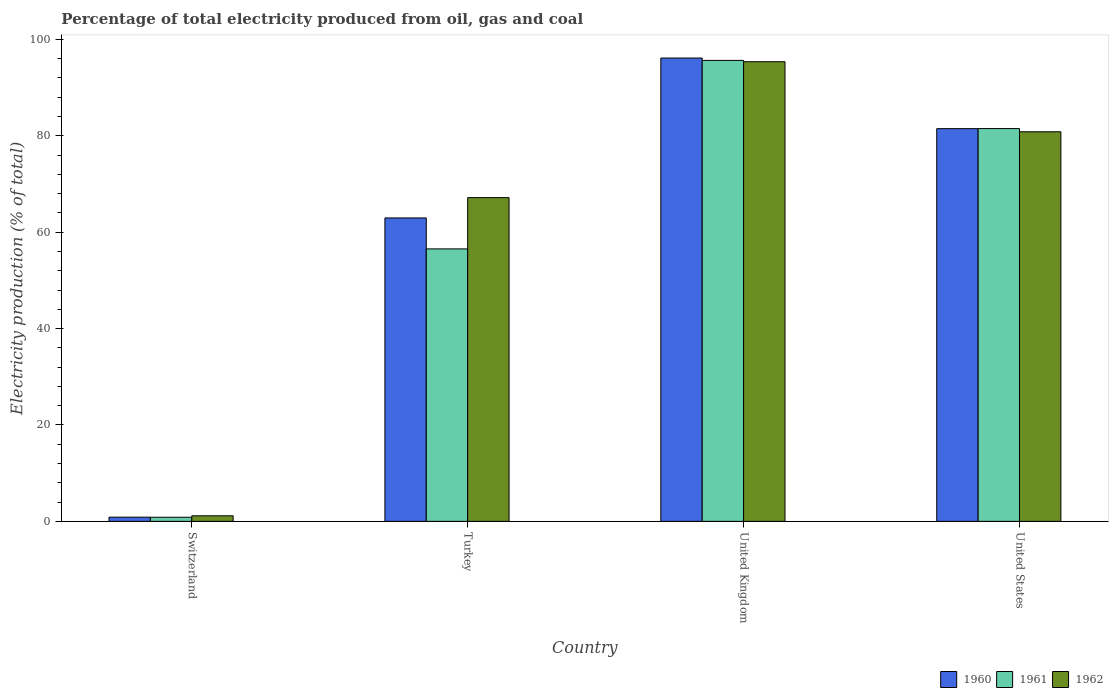How many different coloured bars are there?
Your answer should be very brief. 3. Are the number of bars per tick equal to the number of legend labels?
Keep it short and to the point. Yes. Are the number of bars on each tick of the X-axis equal?
Offer a very short reply. Yes. How many bars are there on the 1st tick from the right?
Provide a succinct answer. 3. What is the electricity production in in 1960 in Switzerland?
Your answer should be compact. 0.87. Across all countries, what is the maximum electricity production in in 1961?
Your answer should be very brief. 95.64. Across all countries, what is the minimum electricity production in in 1961?
Offer a very short reply. 0.85. In which country was the electricity production in in 1961 maximum?
Your answer should be compact. United Kingdom. In which country was the electricity production in in 1960 minimum?
Provide a short and direct response. Switzerland. What is the total electricity production in in 1961 in the graph?
Keep it short and to the point. 234.51. What is the difference between the electricity production in in 1960 in Switzerland and that in United Kingdom?
Provide a succinct answer. -95.25. What is the difference between the electricity production in in 1960 in Switzerland and the electricity production in in 1962 in United States?
Offer a very short reply. -79.96. What is the average electricity production in in 1961 per country?
Give a very brief answer. 58.63. What is the difference between the electricity production in of/in 1960 and electricity production in of/in 1961 in United States?
Give a very brief answer. -0.02. What is the ratio of the electricity production in in 1962 in Switzerland to that in United Kingdom?
Provide a short and direct response. 0.01. Is the difference between the electricity production in in 1960 in Switzerland and United States greater than the difference between the electricity production in in 1961 in Switzerland and United States?
Give a very brief answer. Yes. What is the difference between the highest and the second highest electricity production in in 1960?
Offer a very short reply. 14.65. What is the difference between the highest and the lowest electricity production in in 1961?
Your response must be concise. 94.78. What does the 2nd bar from the right in Turkey represents?
Your answer should be very brief. 1961. How many bars are there?
Your answer should be very brief. 12. Are all the bars in the graph horizontal?
Offer a very short reply. No. What is the difference between two consecutive major ticks on the Y-axis?
Provide a succinct answer. 20. Does the graph contain any zero values?
Your answer should be very brief. No. How are the legend labels stacked?
Your response must be concise. Horizontal. What is the title of the graph?
Your answer should be very brief. Percentage of total electricity produced from oil, gas and coal. Does "2013" appear as one of the legend labels in the graph?
Provide a short and direct response. No. What is the label or title of the X-axis?
Make the answer very short. Country. What is the label or title of the Y-axis?
Your response must be concise. Electricity production (% of total). What is the Electricity production (% of total) in 1960 in Switzerland?
Keep it short and to the point. 0.87. What is the Electricity production (% of total) of 1961 in Switzerland?
Provide a succinct answer. 0.85. What is the Electricity production (% of total) in 1962 in Switzerland?
Offer a very short reply. 1.15. What is the Electricity production (% of total) of 1960 in Turkey?
Give a very brief answer. 62.95. What is the Electricity production (% of total) of 1961 in Turkey?
Your response must be concise. 56.53. What is the Electricity production (% of total) of 1962 in Turkey?
Provide a succinct answer. 67.16. What is the Electricity production (% of total) of 1960 in United Kingdom?
Ensure brevity in your answer.  96.12. What is the Electricity production (% of total) of 1961 in United Kingdom?
Offer a terse response. 95.64. What is the Electricity production (% of total) in 1962 in United Kingdom?
Provide a succinct answer. 95.36. What is the Electricity production (% of total) in 1960 in United States?
Make the answer very short. 81.48. What is the Electricity production (% of total) of 1961 in United States?
Provide a short and direct response. 81.49. What is the Electricity production (% of total) in 1962 in United States?
Offer a very short reply. 80.83. Across all countries, what is the maximum Electricity production (% of total) of 1960?
Give a very brief answer. 96.12. Across all countries, what is the maximum Electricity production (% of total) of 1961?
Keep it short and to the point. 95.64. Across all countries, what is the maximum Electricity production (% of total) in 1962?
Offer a terse response. 95.36. Across all countries, what is the minimum Electricity production (% of total) of 1960?
Your answer should be very brief. 0.87. Across all countries, what is the minimum Electricity production (% of total) in 1961?
Keep it short and to the point. 0.85. Across all countries, what is the minimum Electricity production (% of total) of 1962?
Make the answer very short. 1.15. What is the total Electricity production (% of total) in 1960 in the graph?
Provide a short and direct response. 241.42. What is the total Electricity production (% of total) in 1961 in the graph?
Make the answer very short. 234.51. What is the total Electricity production (% of total) of 1962 in the graph?
Offer a terse response. 244.5. What is the difference between the Electricity production (% of total) of 1960 in Switzerland and that in Turkey?
Keep it short and to the point. -62.08. What is the difference between the Electricity production (% of total) in 1961 in Switzerland and that in Turkey?
Give a very brief answer. -55.67. What is the difference between the Electricity production (% of total) of 1962 in Switzerland and that in Turkey?
Keep it short and to the point. -66.01. What is the difference between the Electricity production (% of total) in 1960 in Switzerland and that in United Kingdom?
Provide a short and direct response. -95.25. What is the difference between the Electricity production (% of total) of 1961 in Switzerland and that in United Kingdom?
Your answer should be compact. -94.78. What is the difference between the Electricity production (% of total) of 1962 in Switzerland and that in United Kingdom?
Keep it short and to the point. -94.21. What is the difference between the Electricity production (% of total) of 1960 in Switzerland and that in United States?
Your answer should be compact. -80.61. What is the difference between the Electricity production (% of total) of 1961 in Switzerland and that in United States?
Keep it short and to the point. -80.64. What is the difference between the Electricity production (% of total) in 1962 in Switzerland and that in United States?
Your answer should be very brief. -79.67. What is the difference between the Electricity production (% of total) of 1960 in Turkey and that in United Kingdom?
Provide a succinct answer. -33.18. What is the difference between the Electricity production (% of total) in 1961 in Turkey and that in United Kingdom?
Your answer should be very brief. -39.11. What is the difference between the Electricity production (% of total) of 1962 in Turkey and that in United Kingdom?
Your answer should be very brief. -28.2. What is the difference between the Electricity production (% of total) in 1960 in Turkey and that in United States?
Your answer should be very brief. -18.53. What is the difference between the Electricity production (% of total) in 1961 in Turkey and that in United States?
Give a very brief answer. -24.97. What is the difference between the Electricity production (% of total) of 1962 in Turkey and that in United States?
Offer a terse response. -13.66. What is the difference between the Electricity production (% of total) in 1960 in United Kingdom and that in United States?
Give a very brief answer. 14.65. What is the difference between the Electricity production (% of total) of 1961 in United Kingdom and that in United States?
Your response must be concise. 14.14. What is the difference between the Electricity production (% of total) of 1962 in United Kingdom and that in United States?
Provide a succinct answer. 14.53. What is the difference between the Electricity production (% of total) in 1960 in Switzerland and the Electricity production (% of total) in 1961 in Turkey?
Make the answer very short. -55.66. What is the difference between the Electricity production (% of total) in 1960 in Switzerland and the Electricity production (% of total) in 1962 in Turkey?
Your answer should be very brief. -66.29. What is the difference between the Electricity production (% of total) in 1961 in Switzerland and the Electricity production (% of total) in 1962 in Turkey?
Keep it short and to the point. -66.31. What is the difference between the Electricity production (% of total) in 1960 in Switzerland and the Electricity production (% of total) in 1961 in United Kingdom?
Your answer should be very brief. -94.77. What is the difference between the Electricity production (% of total) of 1960 in Switzerland and the Electricity production (% of total) of 1962 in United Kingdom?
Keep it short and to the point. -94.49. What is the difference between the Electricity production (% of total) of 1961 in Switzerland and the Electricity production (% of total) of 1962 in United Kingdom?
Ensure brevity in your answer.  -94.51. What is the difference between the Electricity production (% of total) of 1960 in Switzerland and the Electricity production (% of total) of 1961 in United States?
Your answer should be compact. -80.62. What is the difference between the Electricity production (% of total) of 1960 in Switzerland and the Electricity production (% of total) of 1962 in United States?
Your answer should be very brief. -79.96. What is the difference between the Electricity production (% of total) in 1961 in Switzerland and the Electricity production (% of total) in 1962 in United States?
Your response must be concise. -79.97. What is the difference between the Electricity production (% of total) in 1960 in Turkey and the Electricity production (% of total) in 1961 in United Kingdom?
Give a very brief answer. -32.69. What is the difference between the Electricity production (% of total) in 1960 in Turkey and the Electricity production (% of total) in 1962 in United Kingdom?
Offer a terse response. -32.41. What is the difference between the Electricity production (% of total) of 1961 in Turkey and the Electricity production (% of total) of 1962 in United Kingdom?
Provide a succinct answer. -38.83. What is the difference between the Electricity production (% of total) of 1960 in Turkey and the Electricity production (% of total) of 1961 in United States?
Make the answer very short. -18.54. What is the difference between the Electricity production (% of total) in 1960 in Turkey and the Electricity production (% of total) in 1962 in United States?
Your answer should be very brief. -17.88. What is the difference between the Electricity production (% of total) of 1961 in Turkey and the Electricity production (% of total) of 1962 in United States?
Provide a short and direct response. -24.3. What is the difference between the Electricity production (% of total) in 1960 in United Kingdom and the Electricity production (% of total) in 1961 in United States?
Provide a succinct answer. 14.63. What is the difference between the Electricity production (% of total) in 1960 in United Kingdom and the Electricity production (% of total) in 1962 in United States?
Offer a terse response. 15.3. What is the difference between the Electricity production (% of total) in 1961 in United Kingdom and the Electricity production (% of total) in 1962 in United States?
Ensure brevity in your answer.  14.81. What is the average Electricity production (% of total) of 1960 per country?
Provide a succinct answer. 60.35. What is the average Electricity production (% of total) in 1961 per country?
Offer a terse response. 58.63. What is the average Electricity production (% of total) in 1962 per country?
Your response must be concise. 61.13. What is the difference between the Electricity production (% of total) of 1960 and Electricity production (% of total) of 1961 in Switzerland?
Provide a succinct answer. 0.02. What is the difference between the Electricity production (% of total) in 1960 and Electricity production (% of total) in 1962 in Switzerland?
Ensure brevity in your answer.  -0.28. What is the difference between the Electricity production (% of total) of 1961 and Electricity production (% of total) of 1962 in Switzerland?
Provide a short and direct response. -0.3. What is the difference between the Electricity production (% of total) in 1960 and Electricity production (% of total) in 1961 in Turkey?
Offer a terse response. 6.42. What is the difference between the Electricity production (% of total) in 1960 and Electricity production (% of total) in 1962 in Turkey?
Provide a succinct answer. -4.21. What is the difference between the Electricity production (% of total) in 1961 and Electricity production (% of total) in 1962 in Turkey?
Give a very brief answer. -10.64. What is the difference between the Electricity production (% of total) of 1960 and Electricity production (% of total) of 1961 in United Kingdom?
Keep it short and to the point. 0.49. What is the difference between the Electricity production (% of total) in 1960 and Electricity production (% of total) in 1962 in United Kingdom?
Offer a very short reply. 0.76. What is the difference between the Electricity production (% of total) in 1961 and Electricity production (% of total) in 1962 in United Kingdom?
Give a very brief answer. 0.28. What is the difference between the Electricity production (% of total) in 1960 and Electricity production (% of total) in 1961 in United States?
Your answer should be compact. -0.02. What is the difference between the Electricity production (% of total) in 1960 and Electricity production (% of total) in 1962 in United States?
Keep it short and to the point. 0.65. What is the difference between the Electricity production (% of total) of 1961 and Electricity production (% of total) of 1962 in United States?
Give a very brief answer. 0.66. What is the ratio of the Electricity production (% of total) of 1960 in Switzerland to that in Turkey?
Your answer should be compact. 0.01. What is the ratio of the Electricity production (% of total) in 1961 in Switzerland to that in Turkey?
Provide a succinct answer. 0.02. What is the ratio of the Electricity production (% of total) in 1962 in Switzerland to that in Turkey?
Your response must be concise. 0.02. What is the ratio of the Electricity production (% of total) of 1960 in Switzerland to that in United Kingdom?
Make the answer very short. 0.01. What is the ratio of the Electricity production (% of total) in 1961 in Switzerland to that in United Kingdom?
Provide a short and direct response. 0.01. What is the ratio of the Electricity production (% of total) in 1962 in Switzerland to that in United Kingdom?
Your answer should be very brief. 0.01. What is the ratio of the Electricity production (% of total) of 1960 in Switzerland to that in United States?
Your answer should be very brief. 0.01. What is the ratio of the Electricity production (% of total) of 1961 in Switzerland to that in United States?
Provide a succinct answer. 0.01. What is the ratio of the Electricity production (% of total) of 1962 in Switzerland to that in United States?
Offer a terse response. 0.01. What is the ratio of the Electricity production (% of total) in 1960 in Turkey to that in United Kingdom?
Provide a succinct answer. 0.65. What is the ratio of the Electricity production (% of total) in 1961 in Turkey to that in United Kingdom?
Ensure brevity in your answer.  0.59. What is the ratio of the Electricity production (% of total) in 1962 in Turkey to that in United Kingdom?
Ensure brevity in your answer.  0.7. What is the ratio of the Electricity production (% of total) of 1960 in Turkey to that in United States?
Give a very brief answer. 0.77. What is the ratio of the Electricity production (% of total) in 1961 in Turkey to that in United States?
Make the answer very short. 0.69. What is the ratio of the Electricity production (% of total) in 1962 in Turkey to that in United States?
Your response must be concise. 0.83. What is the ratio of the Electricity production (% of total) in 1960 in United Kingdom to that in United States?
Make the answer very short. 1.18. What is the ratio of the Electricity production (% of total) of 1961 in United Kingdom to that in United States?
Provide a succinct answer. 1.17. What is the ratio of the Electricity production (% of total) of 1962 in United Kingdom to that in United States?
Provide a succinct answer. 1.18. What is the difference between the highest and the second highest Electricity production (% of total) of 1960?
Offer a terse response. 14.65. What is the difference between the highest and the second highest Electricity production (% of total) in 1961?
Your response must be concise. 14.14. What is the difference between the highest and the second highest Electricity production (% of total) of 1962?
Your response must be concise. 14.53. What is the difference between the highest and the lowest Electricity production (% of total) of 1960?
Ensure brevity in your answer.  95.25. What is the difference between the highest and the lowest Electricity production (% of total) in 1961?
Your response must be concise. 94.78. What is the difference between the highest and the lowest Electricity production (% of total) in 1962?
Your answer should be compact. 94.21. 